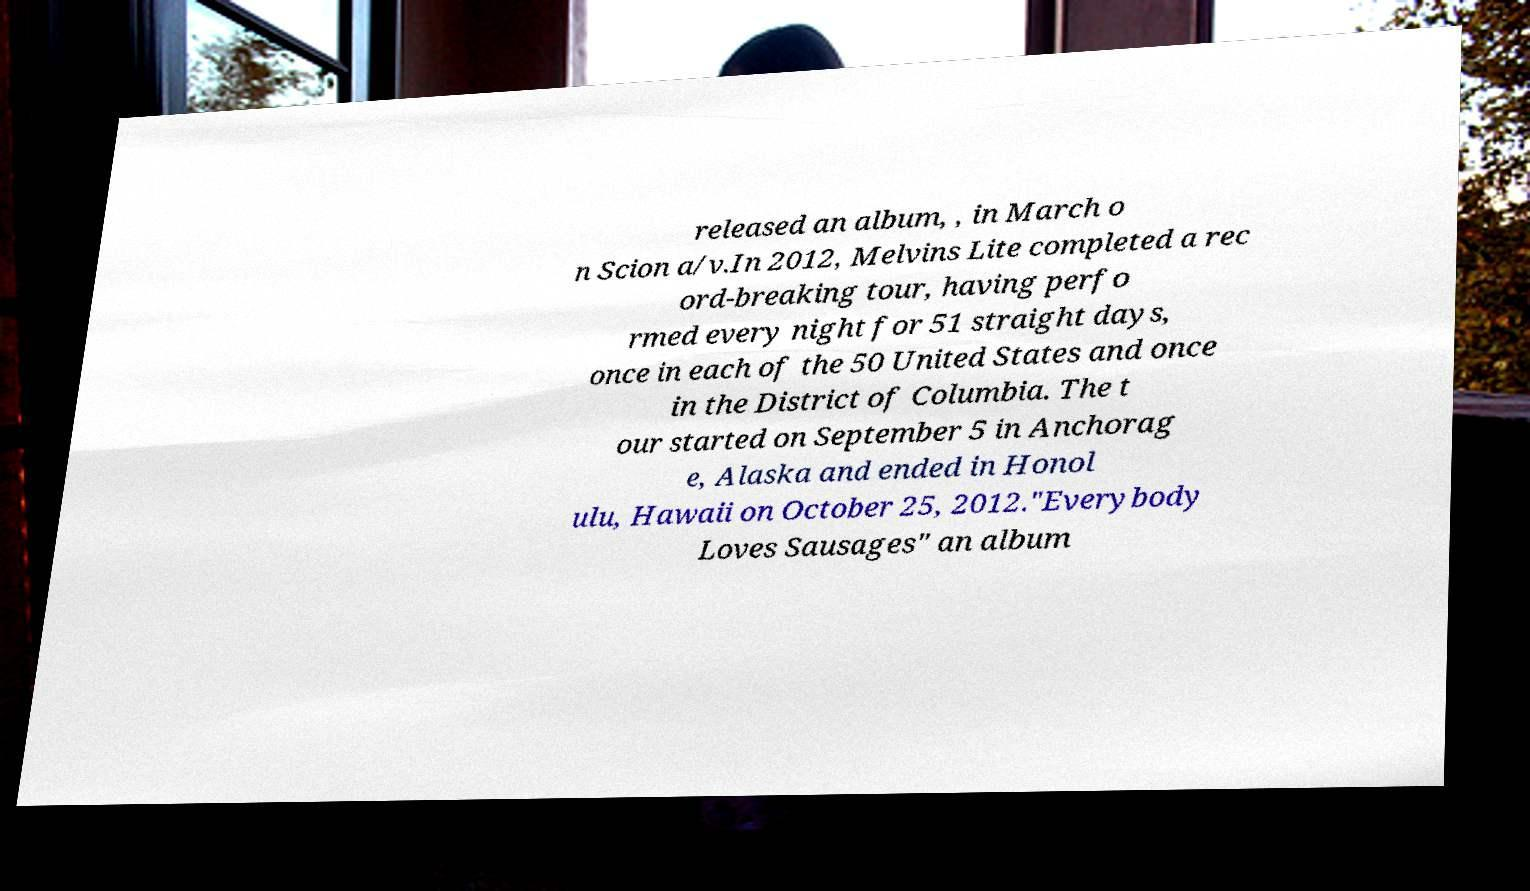For documentation purposes, I need the text within this image transcribed. Could you provide that? released an album, , in March o n Scion a/v.In 2012, Melvins Lite completed a rec ord-breaking tour, having perfo rmed every night for 51 straight days, once in each of the 50 United States and once in the District of Columbia. The t our started on September 5 in Anchorag e, Alaska and ended in Honol ulu, Hawaii on October 25, 2012."Everybody Loves Sausages" an album 